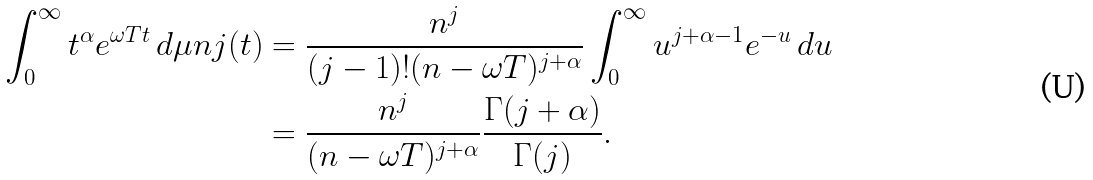Convert formula to latex. <formula><loc_0><loc_0><loc_500><loc_500>\int _ { 0 } ^ { \infty } t ^ { \alpha } e ^ { \omega T t } \, d \mu n j ( t ) & = \frac { n ^ { j } } { ( j - 1 ) ! ( n - \omega T ) ^ { j + \alpha } } \int _ { 0 } ^ { \infty } u ^ { j + \alpha - 1 } e ^ { - u } \, d u \\ & = \frac { n ^ { j } } { ( n - \omega T ) ^ { j + \alpha } } \frac { \Gamma ( j + \alpha ) } { \Gamma ( j ) } .</formula> 